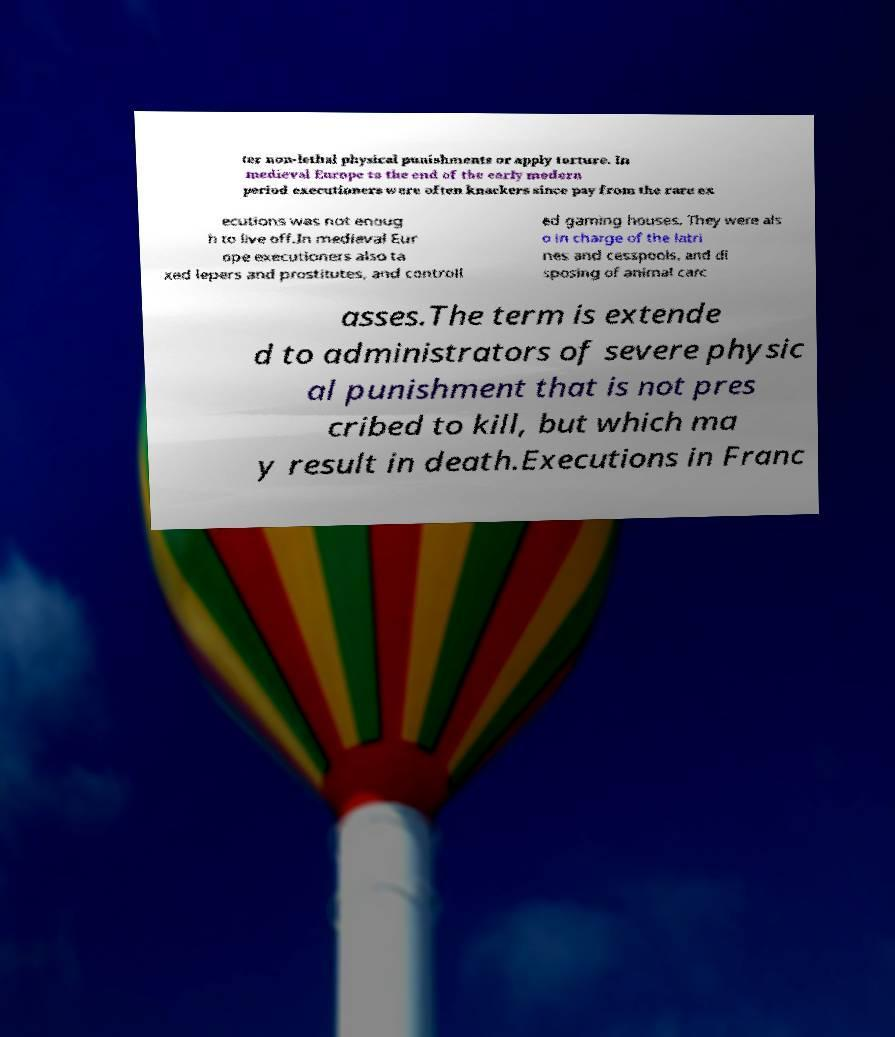For documentation purposes, I need the text within this image transcribed. Could you provide that? ter non-lethal physical punishments or apply torture. In medieval Europe to the end of the early modern period executioners were often knackers since pay from the rare ex ecutions was not enoug h to live off.In medieval Eur ope executioners also ta xed lepers and prostitutes, and controll ed gaming houses. They were als o in charge of the latri nes and cesspools, and di sposing of animal carc asses.The term is extende d to administrators of severe physic al punishment that is not pres cribed to kill, but which ma y result in death.Executions in Franc 